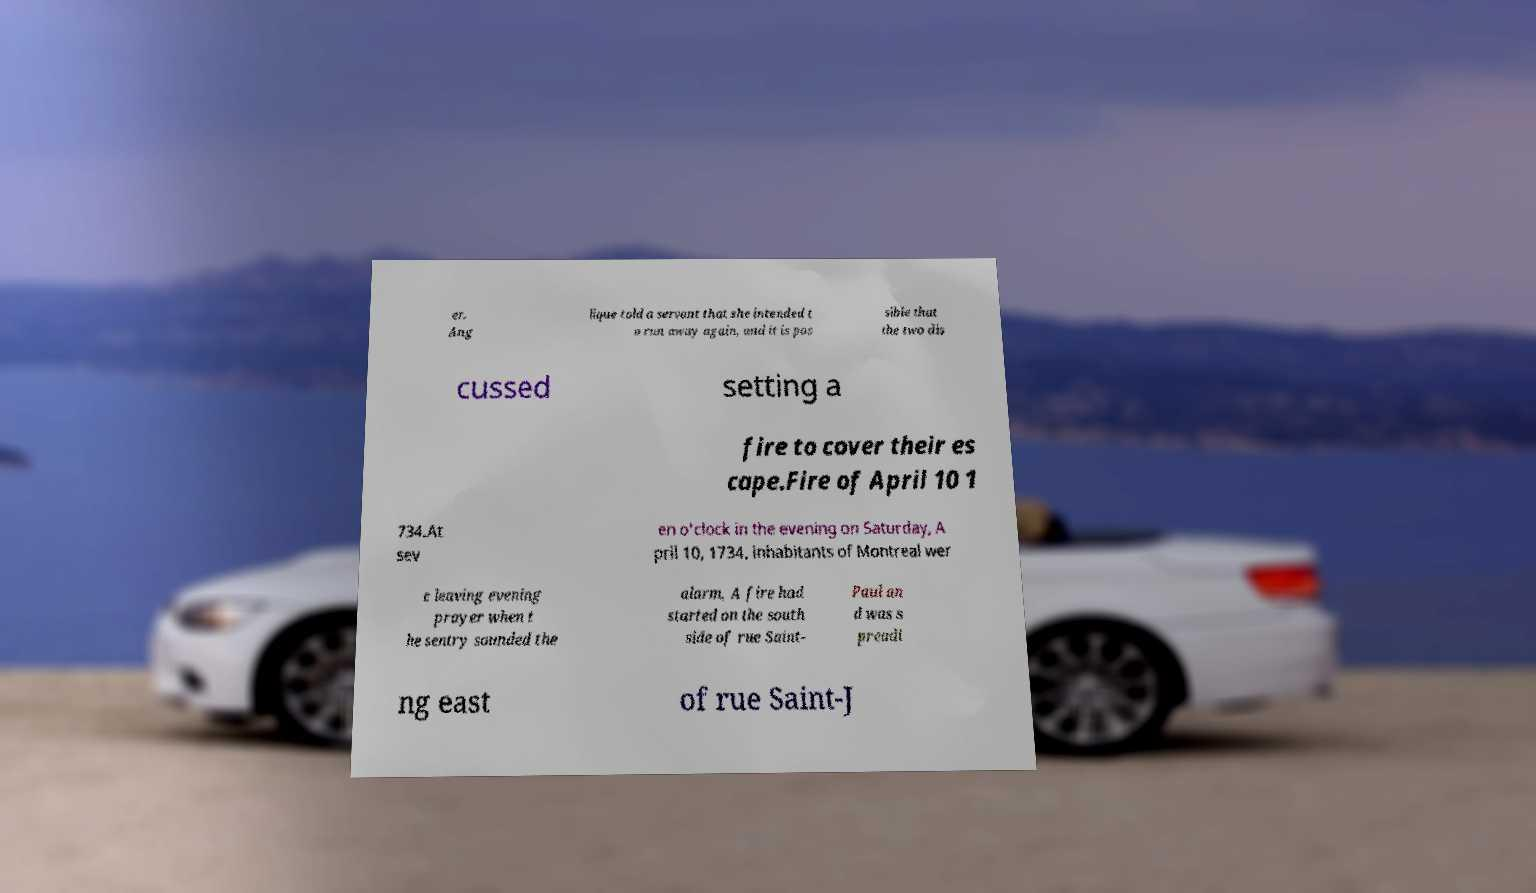Could you extract and type out the text from this image? er. Ang lique told a servant that she intended t o run away again, and it is pos sible that the two dis cussed setting a fire to cover their es cape.Fire of April 10 1 734.At sev en o'clock in the evening on Saturday, A pril 10, 1734, inhabitants of Montreal wer e leaving evening prayer when t he sentry sounded the alarm, A fire had started on the south side of rue Saint- Paul an d was s preadi ng east of rue Saint-J 